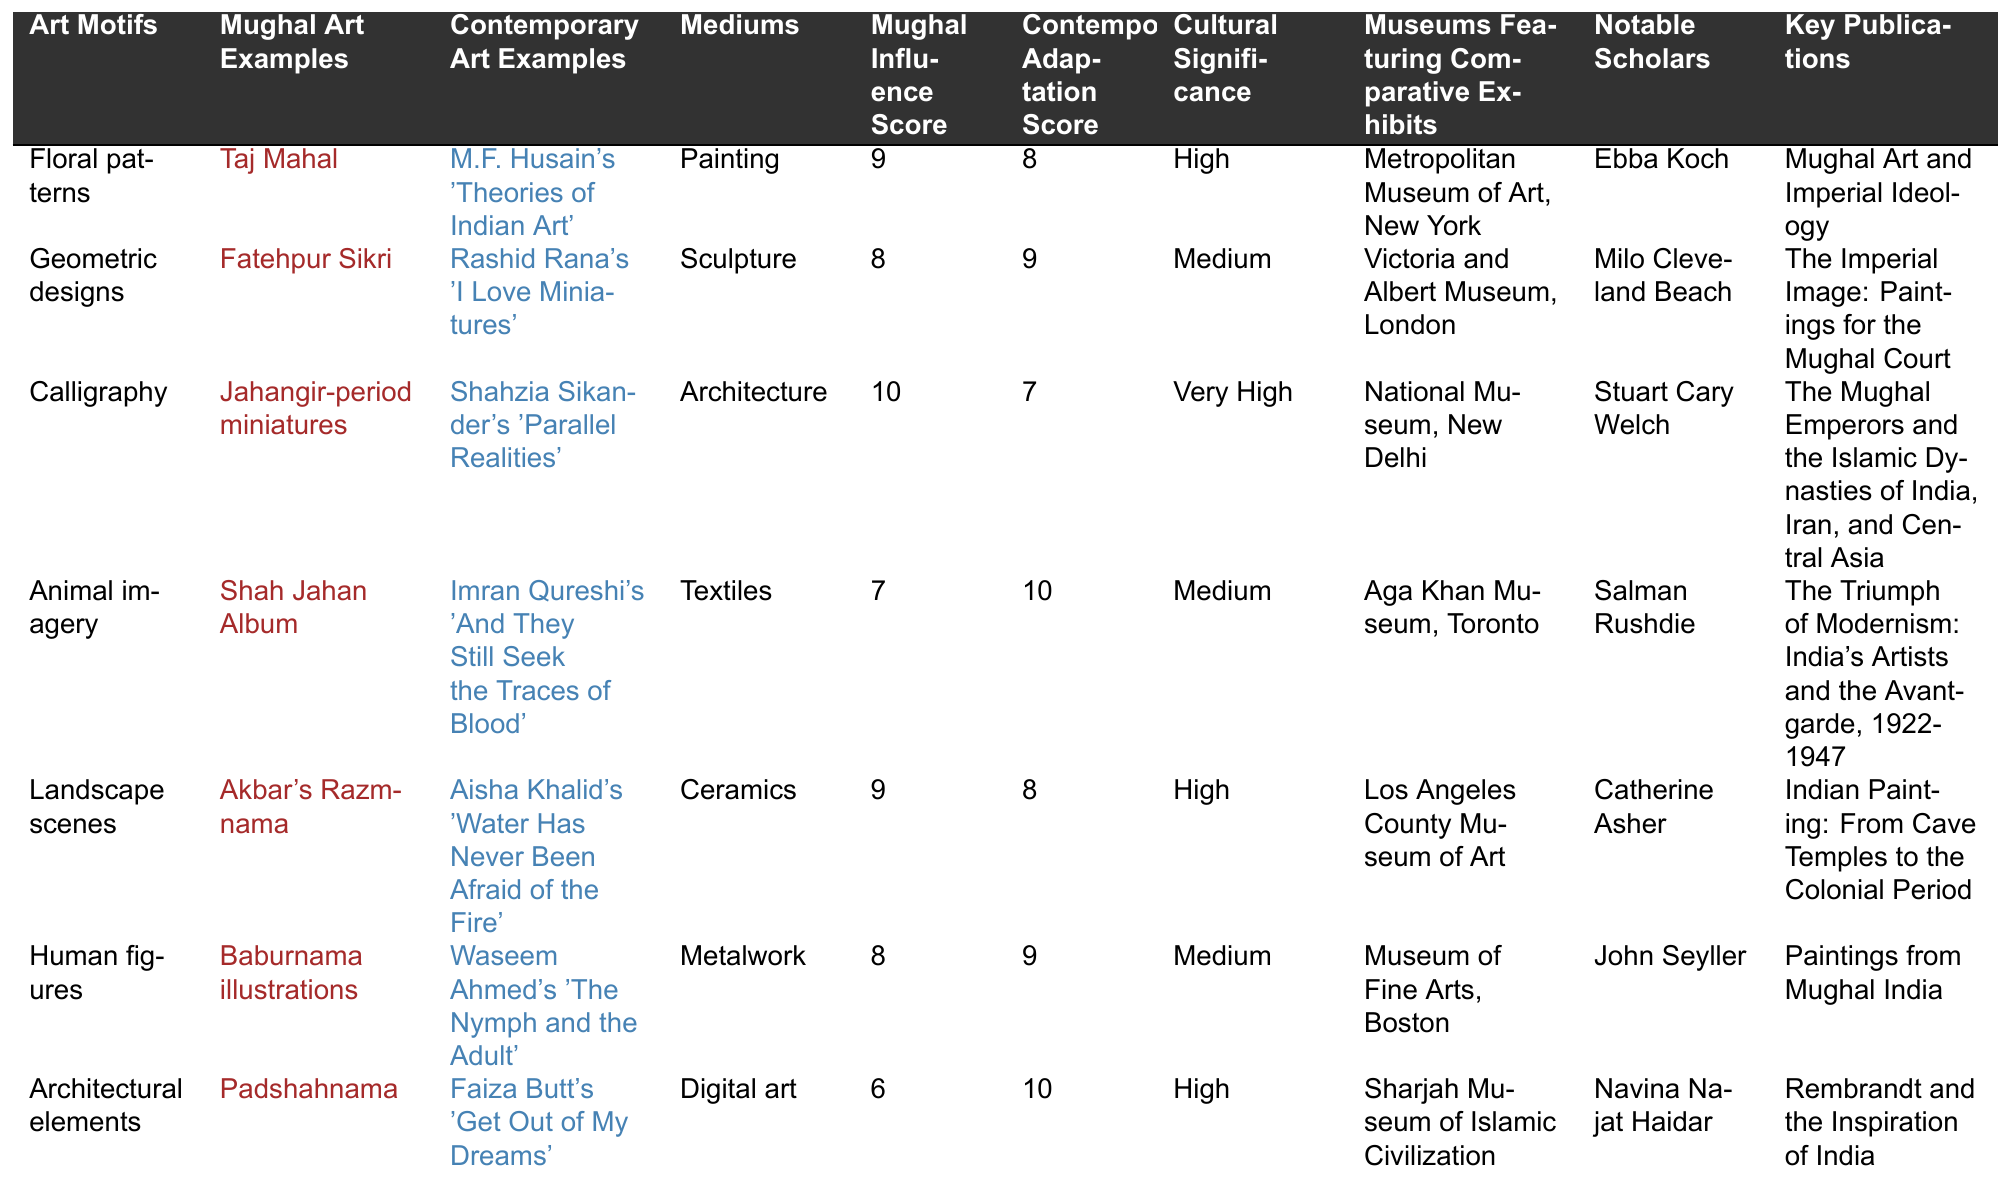What is the Mughal Influence Score for calligraphy? In the table, I locate the row for calligraphy, which shows a Mughal Influence Score of 10.
Answer: 10 Which contemporary art example corresponds to animal imagery? I look at the row for animal imagery, and it lists Imran Qureshi's 'And They Still Seek the Traces of Blood' as the contemporary art example.
Answer: Imran Qureshi's 'And They Still Seek the Traces of Blood' What are the mediums associated with geometric designs? In the geometric designs row, the medium listed is sculpture.
Answer: Sculpture What is the average Mughal Influence Score for all art motifs? To find the average, I add the Mughal Influence Scores: 9 + 8 + 10 + 7 + 9 + 8 + 6 = 57. Then, I divide by the number of motifs (7), which gives 57/7 = 8.14.
Answer: 8.14 Is the cultural significance of human figures classified as high? Referring to the human figures row, the cultural significance is marked as medium, indicating that it is not classified as high.
Answer: No Which museum has an exhibit for Mughal art examples related to landscapes? I check the landscape scenes row, which indicates that the Los Angeles County Museum of Art features comparative exhibits for that motif.
Answer: Los Angeles County Museum of Art What is the difference between the Mughal Influence Score and the Contemporary Adaptation Score for floral patterns? For floral patterns, the Mughal Influence Score is 9 and the Contemporary Adaptation Score is 8. The difference is 9 - 8 = 1.
Answer: 1 Which notable scholar is associated with the publication "The Triumph of Modernism: India's Artists and the Avant-garde, 1922-1947"? In the table, I identify that Salman Rushdie is associated with that specific publication.
Answer: Salman Rushdie How many contemporary art examples have a Contemporary Adaptation Score of 10? In the table, I observe two contemporary art examples with a score of 10: Imran Qureshi's work and Faiza Butt's work.
Answer: 2 What is the sum of the Mughal Influence Scores for architectural elements and landscape scenes? The Mughal Influence Score for architectural elements is 6 and for landscape scenes is 9. Adding these together gives 6 + 9 = 15.
Answer: 15 